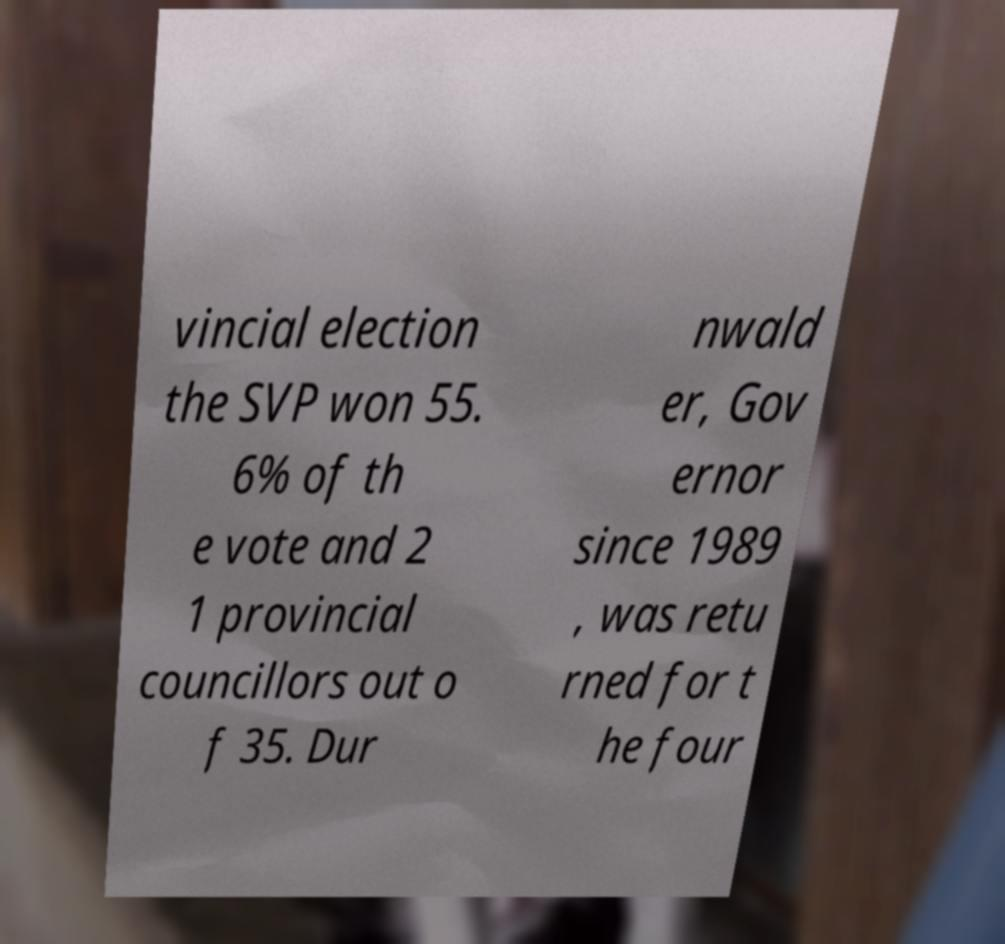Could you assist in decoding the text presented in this image and type it out clearly? vincial election the SVP won 55. 6% of th e vote and 2 1 provincial councillors out o f 35. Dur nwald er, Gov ernor since 1989 , was retu rned for t he four 